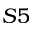Convert formula to latex. <formula><loc_0><loc_0><loc_500><loc_500>S 5</formula> 